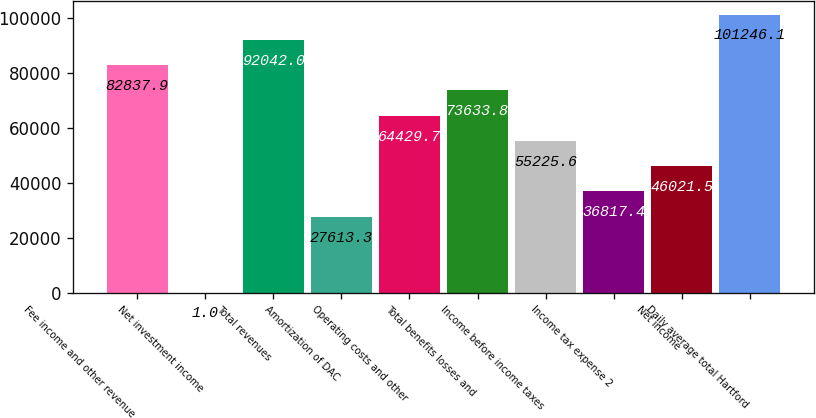<chart> <loc_0><loc_0><loc_500><loc_500><bar_chart><fcel>Fee income and other revenue<fcel>Net investment income<fcel>Total revenues<fcel>Amortization of DAC<fcel>Operating costs and other<fcel>Total benefits losses and<fcel>Income before income taxes<fcel>Income tax expense 2<fcel>Net income<fcel>Daily average total Hartford<nl><fcel>82837.9<fcel>1<fcel>92042<fcel>27613.3<fcel>64429.7<fcel>73633.8<fcel>55225.6<fcel>36817.4<fcel>46021.5<fcel>101246<nl></chart> 